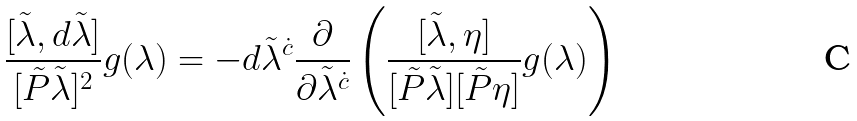<formula> <loc_0><loc_0><loc_500><loc_500>\frac { [ \tilde { \lambda } , d \tilde { \lambda } ] } { [ \tilde { P } \tilde { \lambda } ] ^ { 2 } } g ( \lambda ) = - d \tilde { \lambda } ^ { \dot { c } } \frac { \partial } { \partial \tilde { \lambda } ^ { \dot { c } } } \left ( \frac { [ \tilde { \lambda } , \eta ] } { [ \tilde { P } \tilde { \lambda } ] [ \tilde { P } \eta ] } g ( \lambda ) \right )</formula> 